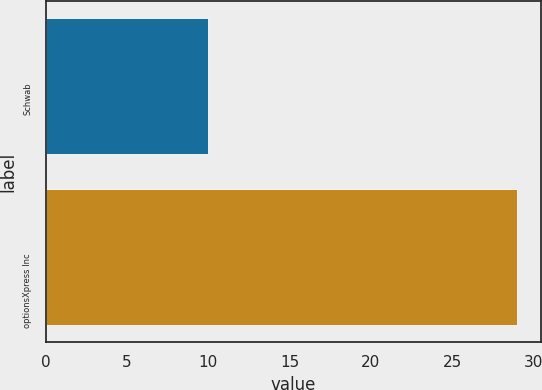<chart> <loc_0><loc_0><loc_500><loc_500><bar_chart><fcel>Schwab<fcel>optionsXpress Inc<nl><fcel>10<fcel>29<nl></chart> 